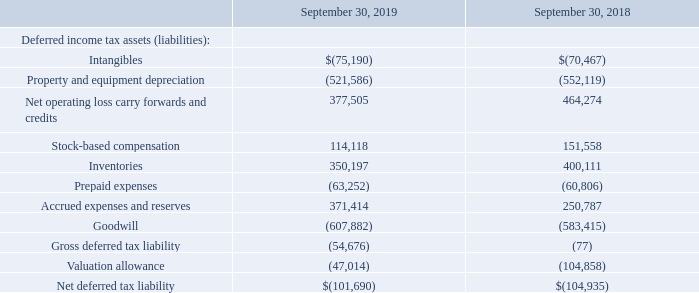Realization of net operating loss carryforwards and other deferred tax temporary differences are contingent upon future taxable earnings. The Company’s deferred tax assets were reviewed for expected utilization by assessing the available positive and negative factors surrounding their recoverability.
As of September 30, 2018, the Company’s remaining valuation allowance of approximately $105,000 related to state net operating loss carry forwards. During the fourth quarter of 2019, the Company reversed approximately $58,000 of its valuation allowance. This consisted of decreasing the valuation allowance for the expiration and utilization of state net operating losses in 2019 of approximately $68,000 and increasing the valuation allowance by approximately $10,000 for future expected NOL utilization based on updated profitability estimates and changes to the loss utilization rules. The remaining valuation allowance balance as of September 30, 2019 of approximately $47,000 relates entirely to state net operating loss carry forwards we do not expect to utilize. The Company will continue to assess the assumptions used to determine the amount of our valuation allowance and may adjust the valuation allowance in future periods based on changes in assumptions of estimated future income and other factors. If the valuation allowance is reduced, we would record an income tax benefit in the period the valuation allowance is reduced. If the valuation allowance is increased, we would record additional income tax expense.
Significant components of deferred income tax assets and liabilities are as follows at:
What is the approximate amount of valuation allowance that the Company has reversed in the forth quarter of 2019? $58,000. What actions will the Company take when the valuation allowance is increased? Record additional income tax expense. What is the gross deferred tax liability as of September 30, 2018? 77. What is the percentage change in the net operating loss carry forwards and credits from 2018 to 2019?
Answer scale should be: percent. (377,505-464,274)/464,274
Answer: -18.69. What is the percentage change in gross deferred tax liability from 2018 to 2019?
Answer scale should be: percent. (54,676-77)/77
Answer: 70907.79. What is the percentage change in the net deferred tax liability from 2018 to 2019?
Answer scale should be: percent. (101,690-104,935)/104,935
Answer: -3.09. 